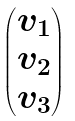<formula> <loc_0><loc_0><loc_500><loc_500>\begin{pmatrix} v _ { 1 } \\ v _ { 2 } \\ v _ { 3 } \end{pmatrix}</formula> 